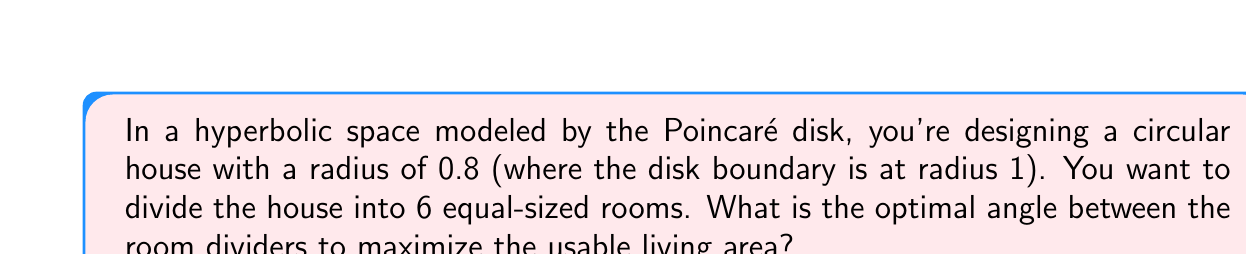Give your solution to this math problem. Let's approach this step-by-step:

1) In hyperbolic geometry, the area of a circular sector in the Poincaré disk model is given by:

   $$A = 2\pi - 2\theta - 2\sin\theta$$

   where $\theta$ is half the central angle of the sector.

2) We want to divide the circle into 6 equal parts, so each room will occupy $\frac{1}{6}$ of the total area.

3) The total area of the circle with radius 0.8 in the Poincaré disk is:

   $$A_{total} = 2\pi - 2\arcsin(0.8) - 2\sqrt{1-0.8^2} \approx 5.2359$$

4) Each room should have an area of:

   $$A_{room} = \frac{A_{total}}{6} \approx 0.8726$$

5) Now, we need to find $\theta$ that satisfies:

   $$0.8726 = 2\pi - 2\theta - 2\sin\theta$$

6) This equation can't be solved algebraically, so we need to use numerical methods. Using a computer algebra system or numerical solver, we find:

   $$\theta \approx 0.5236$$

7) The full angle between room dividers is $2\theta$:

   $$\text{Angle} = 2 * 0.5236 \approx 1.0472$$

8) Converting to degrees:

   $$1.0472 \text{ radians} * \frac{180}{\pi} \approx 60°$$

This result matches our intuition: in a hyperbolic space, the optimal division of a circle into 6 equal parts is the same as in Euclidean space - 60° angles.
Answer: 60° 